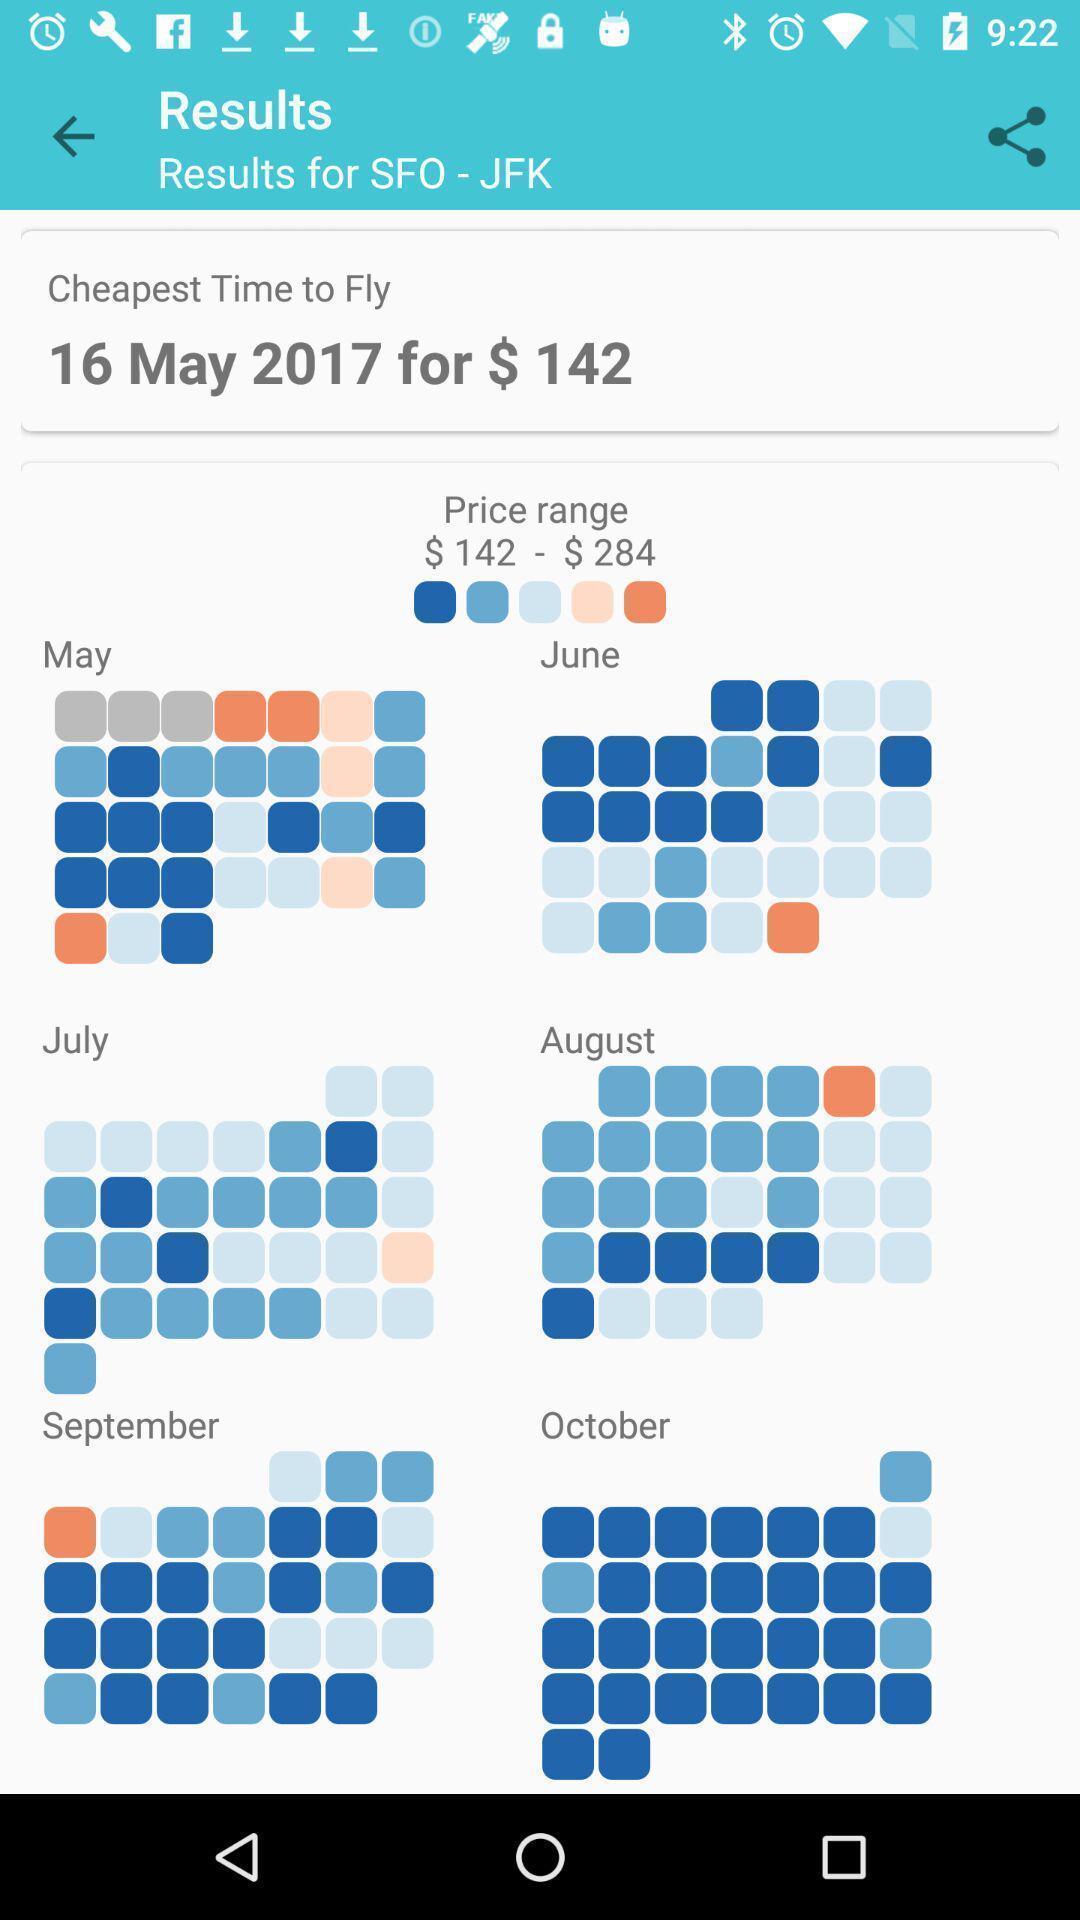Describe this image in words. Screen shows cost range details in an travel app. 